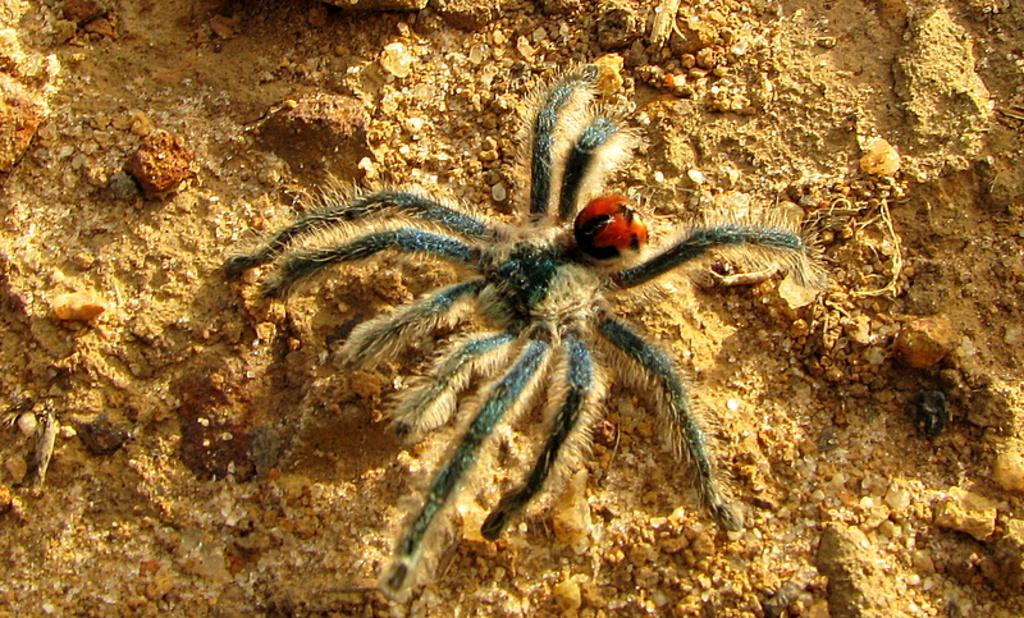What is the main subject in the middle of the image? There is a spider in the middle of the image. What can be seen at the bottom of the image? There are stones at the bottom of the image. How many snakes are slithering around the spider in the image? There are no snakes present in the image; it only features a spider and stones. What force is causing the spider to levitate above the stones in the image? There is no indication of any force causing the spider to levitate in the image; it is resting on the stones. 